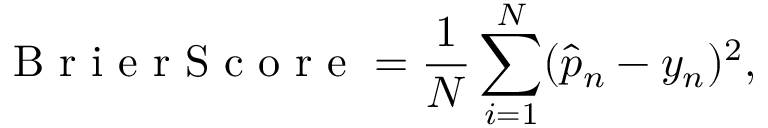Convert formula to latex. <formula><loc_0><loc_0><loc_500><loc_500>B r i e r S c o r e = \frac { 1 } { N } \sum _ { i = 1 } ^ { N } ( \hat { p } _ { n } - y _ { n } ) ^ { 2 } ,</formula> 